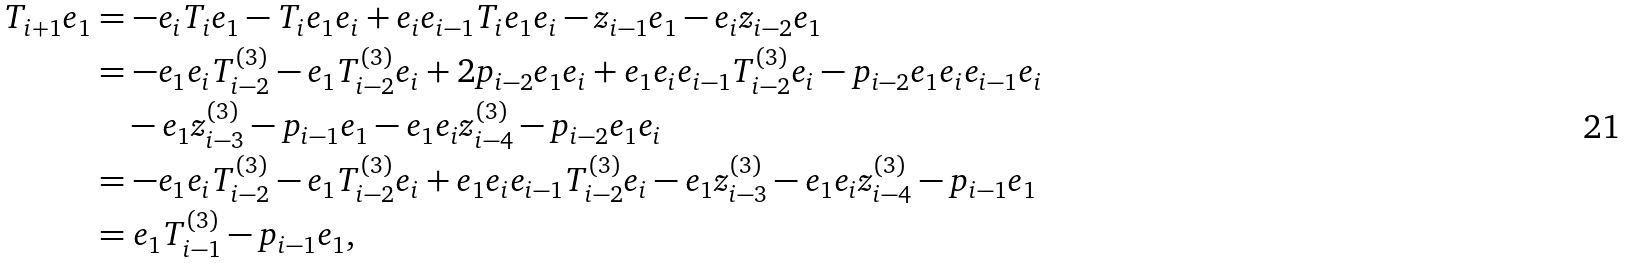Convert formula to latex. <formula><loc_0><loc_0><loc_500><loc_500>T _ { i + 1 } e _ { 1 } & = - e _ { i } T _ { i } e _ { 1 } - T _ { i } e _ { 1 } e _ { i } + e _ { i } e _ { i - 1 } T _ { i } e _ { 1 } e _ { i } - z _ { i - 1 } e _ { 1 } - e _ { i } z _ { i - 2 } e _ { 1 } \\ & = - e _ { 1 } e _ { i } T _ { i - 2 } ^ { ( 3 ) } - e _ { 1 } T _ { i - 2 } ^ { ( 3 ) } e _ { i } + 2 p _ { i - 2 } e _ { 1 } e _ { i } + e _ { 1 } e _ { i } e _ { i - 1 } T _ { i - 2 } ^ { ( 3 ) } e _ { i } - p _ { i - 2 } e _ { 1 } e _ { i } e _ { i - 1 } e _ { i } \\ & \quad - e _ { 1 } z _ { i - 3 } ^ { ( 3 ) } - p _ { i - 1 } e _ { 1 } - e _ { 1 } e _ { i } z _ { i - 4 } ^ { ( 3 ) } - p _ { i - 2 } e _ { 1 } e _ { i } \\ & = - e _ { 1 } e _ { i } T _ { i - 2 } ^ { ( 3 ) } - e _ { 1 } T _ { i - 2 } ^ { ( 3 ) } e _ { i } + e _ { 1 } e _ { i } e _ { i - 1 } T _ { i - 2 } ^ { ( 3 ) } e _ { i } - e _ { 1 } z _ { i - 3 } ^ { ( 3 ) } - e _ { 1 } e _ { i } z _ { i - 4 } ^ { ( 3 ) } - p _ { i - 1 } e _ { 1 } \\ & = e _ { 1 } T _ { i - 1 } ^ { ( 3 ) } - p _ { i - 1 } e _ { 1 } ,</formula> 